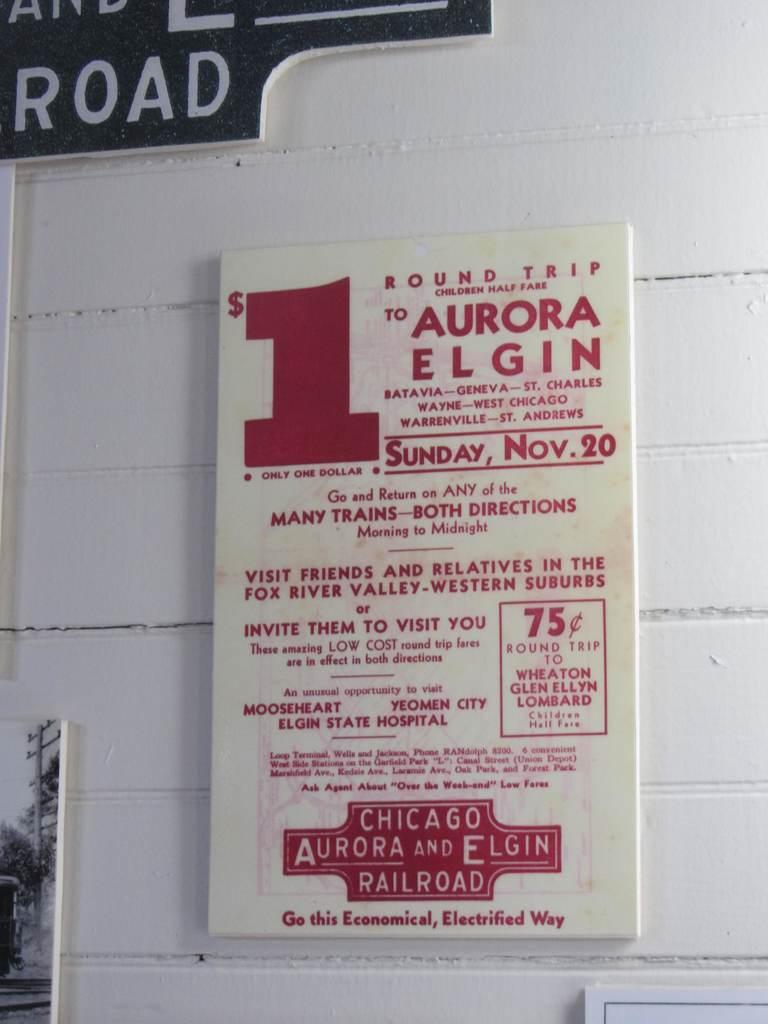How much was a round trip?
Keep it short and to the point. $1. Is chicago aurora and elgin railroad still in existence?
Your answer should be compact. Unanswerable. 